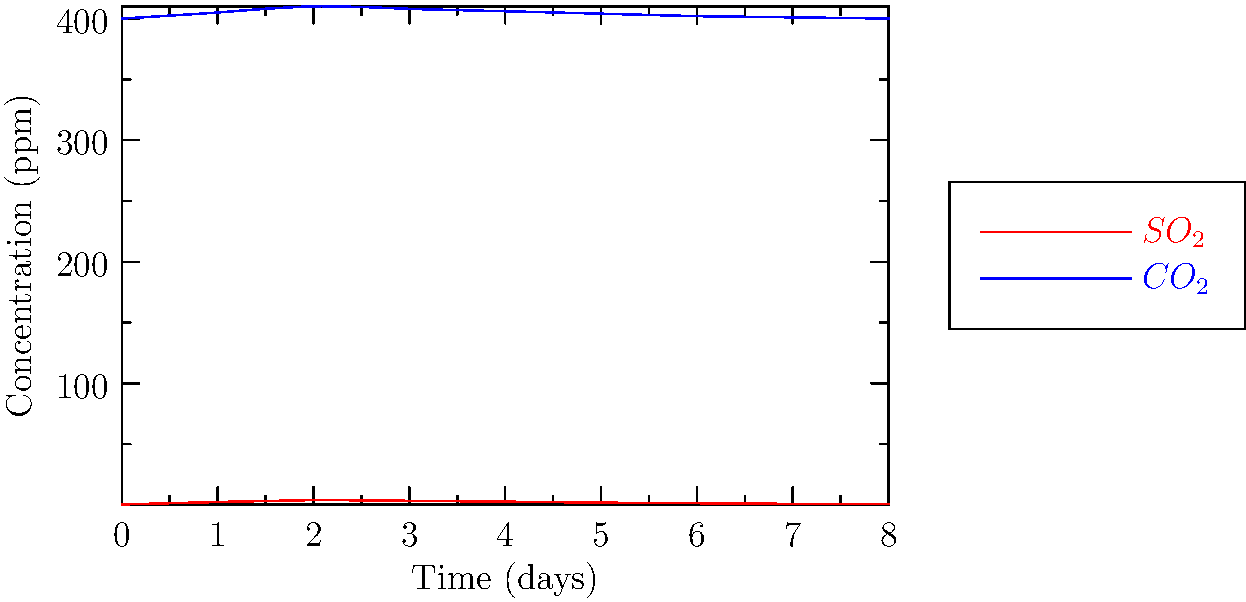Analyze the spectral data graph showing changes in atmospheric composition due to volcanic gases. What is the approximate time delay (in days) between the peak SO₂ concentration and when the CO₂ concentration returns to its initial level? To answer this question, we need to follow these steps:

1. Identify the peak SO₂ concentration:
   From the red curve, we can see that SO₂ concentration peaks at day 2.

2. Determine the initial CO₂ concentration:
   The blue curve shows that the initial CO₂ concentration is 400 ppm at day 0.

3. Find when CO₂ returns to its initial level:
   Tracing the blue curve, we can see that CO₂ concentration returns to approximately 400 ppm at day 8.

4. Calculate the time delay:
   Time delay = Day when CO₂ returns to initial level - Day of peak SO₂ concentration
               = 8 - 2 = 6 days

This delay represents the time it takes for the atmospheric system to process and remove the excess CO₂ introduced by the volcanic eruption, after the initial spike in SO₂ concentration.
Answer: 6 days 